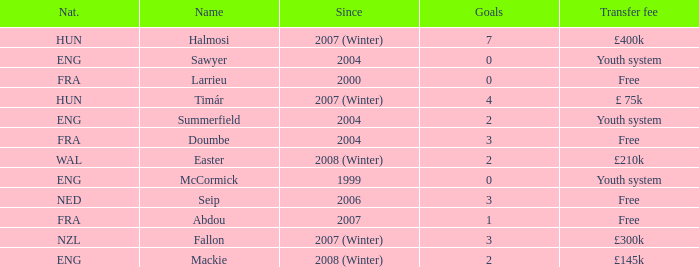Could you parse the entire table as a dict? {'header': ['Nat.', 'Name', 'Since', 'Goals', 'Transfer fee'], 'rows': [['HUN', 'Halmosi', '2007 (Winter)', '7', '£400k'], ['ENG', 'Sawyer', '2004', '0', 'Youth system'], ['FRA', 'Larrieu', '2000', '0', 'Free'], ['HUN', 'Timár', '2007 (Winter)', '4', '£ 75k'], ['ENG', 'Summerfield', '2004', '2', 'Youth system'], ['FRA', 'Doumbe', '2004', '3', 'Free'], ['WAL', 'Easter', '2008 (Winter)', '2', '£210k'], ['ENG', 'McCormick', '1999', '0', 'Youth system'], ['NED', 'Seip', '2006', '3', 'Free'], ['FRA', 'Abdou', '2007', '1', 'Free'], ['NZL', 'Fallon', '2007 (Winter)', '3', '£300k'], ['ENG', 'Mackie', '2008 (Winter)', '2', '£145k']]} What is the average goals Sawyer has? 0.0. 